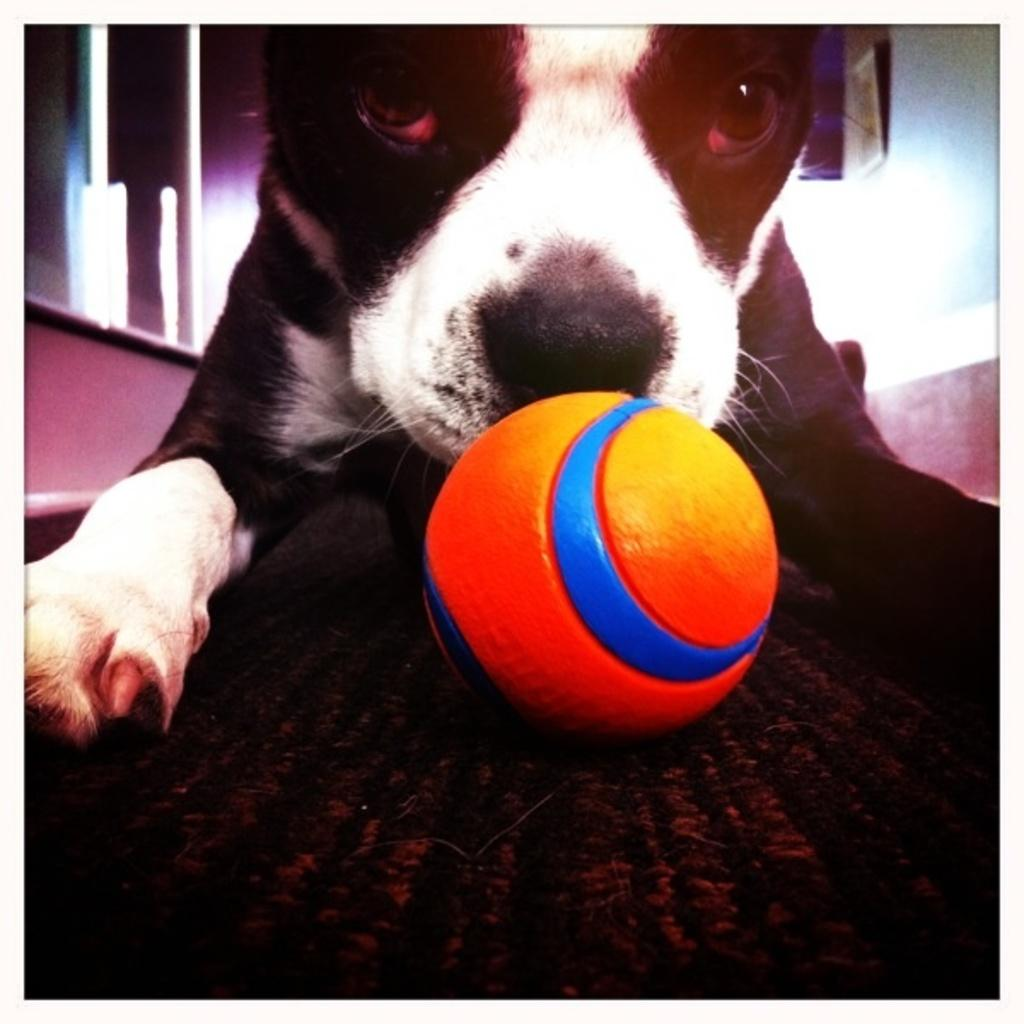What type of animal is in the image? There is a black color dog in the image. Where is the dog located in the image? The dog is in the front of the image. What object is near the dog? There is a ball in the image, and it is near the dog. What can be seen in the background of the image? There is a wall in the background of the image. What type of cloth is being used by the dog to attempt a dock jump in the image? There is no dock, cloth, or dock jump attempt present in the image. 